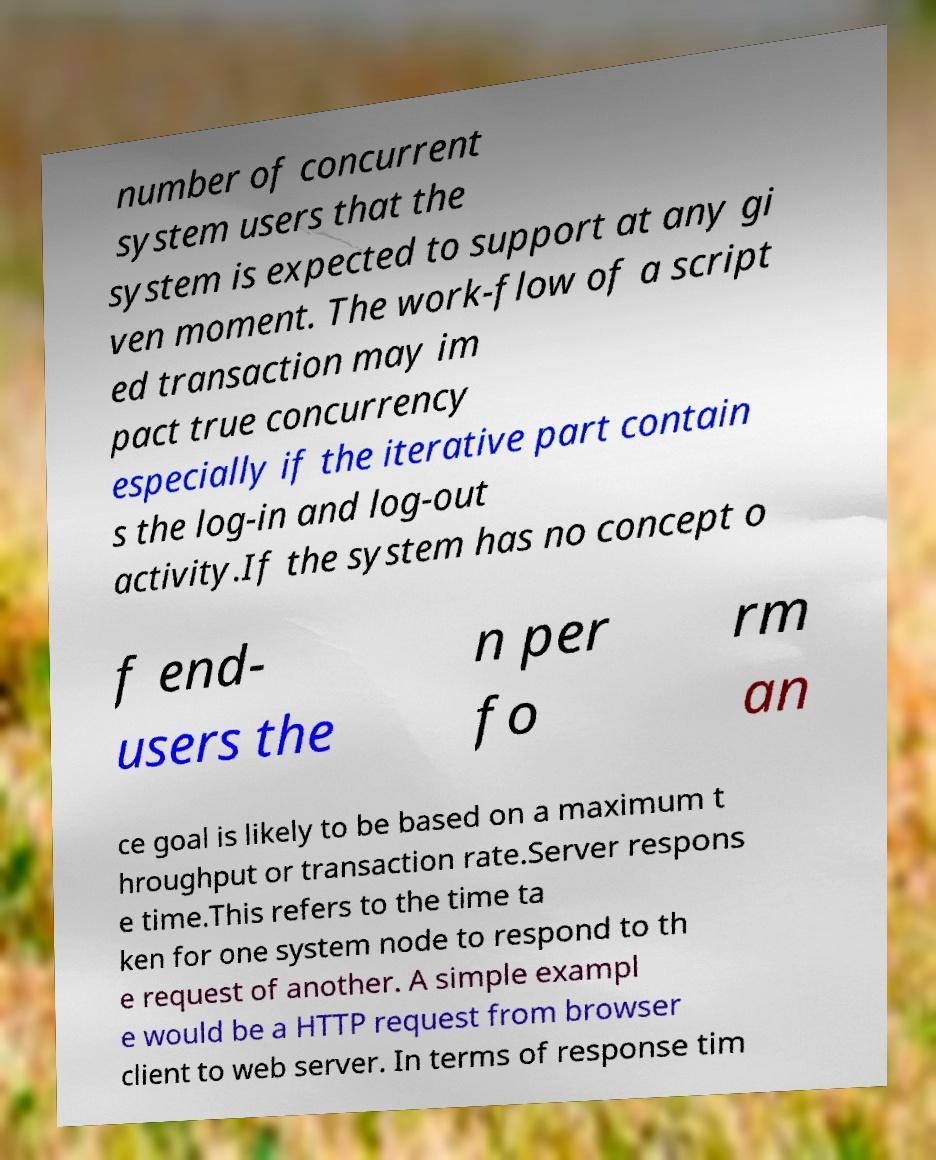Could you extract and type out the text from this image? number of concurrent system users that the system is expected to support at any gi ven moment. The work-flow of a script ed transaction may im pact true concurrency especially if the iterative part contain s the log-in and log-out activity.If the system has no concept o f end- users the n per fo rm an ce goal is likely to be based on a maximum t hroughput or transaction rate.Server respons e time.This refers to the time ta ken for one system node to respond to th e request of another. A simple exampl e would be a HTTP request from browser client to web server. In terms of response tim 